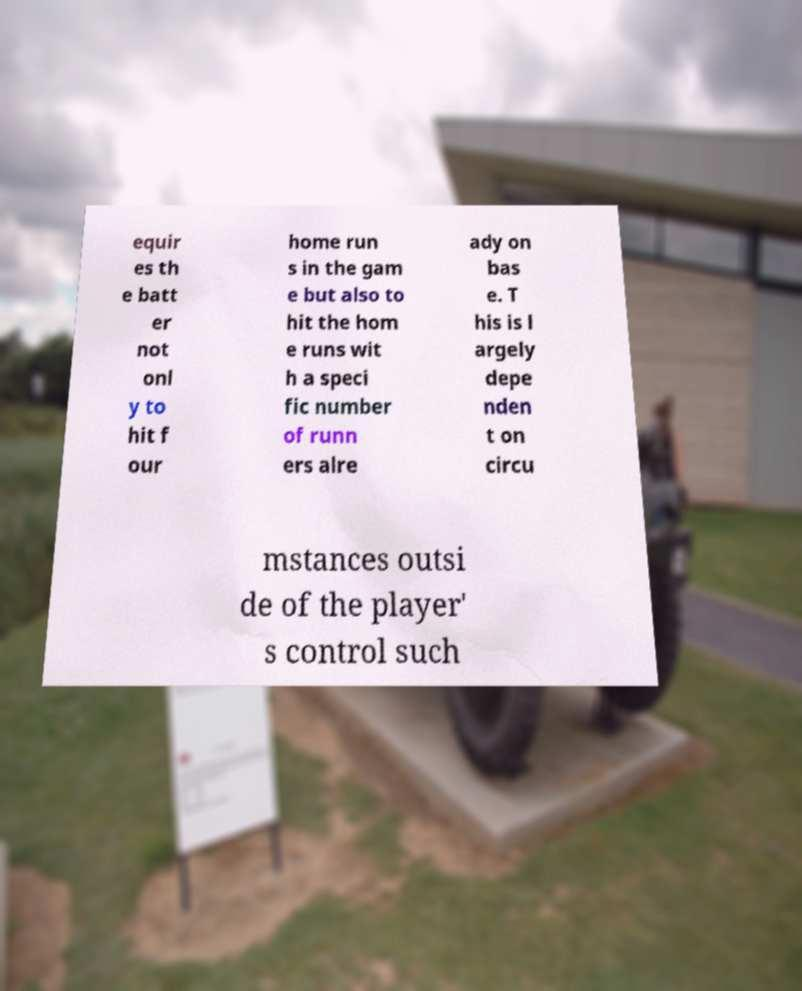I need the written content from this picture converted into text. Can you do that? equir es th e batt er not onl y to hit f our home run s in the gam e but also to hit the hom e runs wit h a speci fic number of runn ers alre ady on bas e. T his is l argely depe nden t on circu mstances outsi de of the player' s control such 